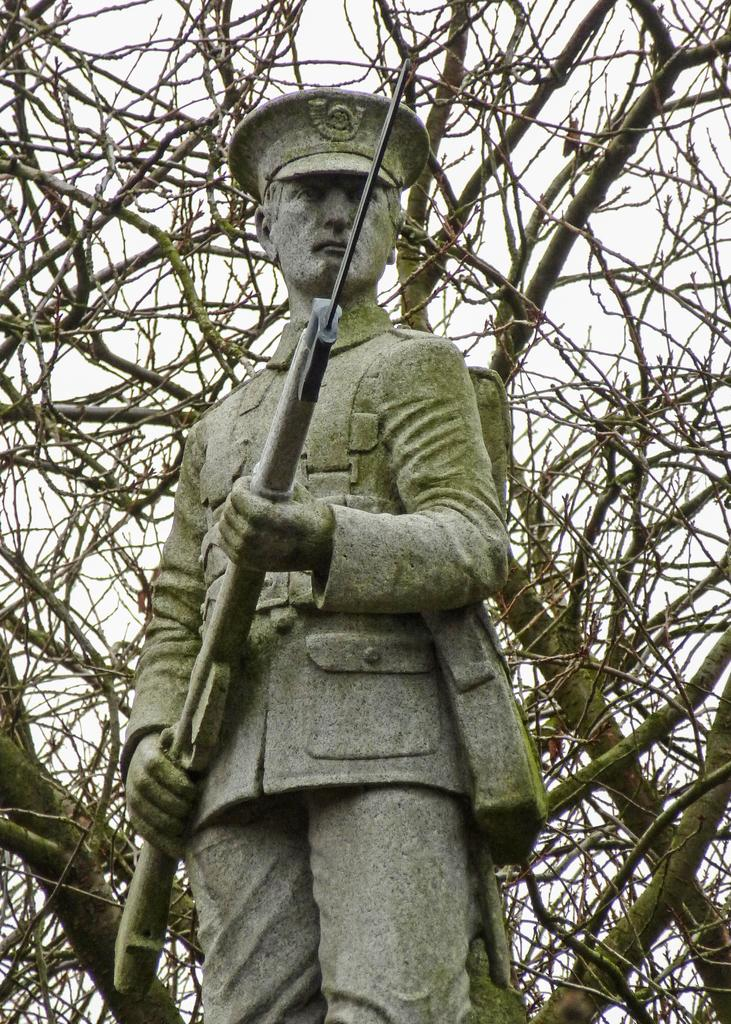What is the main subject of the image? There is a statue of a person in the image. How is the person depicted in the statue? The person is standing and holding a gun. What type of vegetation can be seen in the background of the image? There are trees at the back of the image. What is visible at the top of the image? The sky is visible at the top of the image. What type of mint is growing near the statue in the image? There is no mint present in the image; only trees can be seen in the background. 